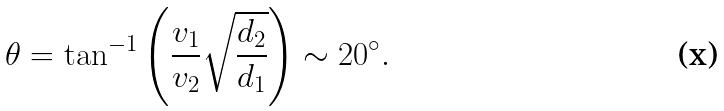Convert formula to latex. <formula><loc_0><loc_0><loc_500><loc_500>\theta = \tan ^ { - 1 } \left ( \frac { v _ { 1 } } { v _ { 2 } } \sqrt { \frac { d _ { 2 } } { d _ { 1 } } } \right ) \sim 2 0 ^ { \circ } .</formula> 